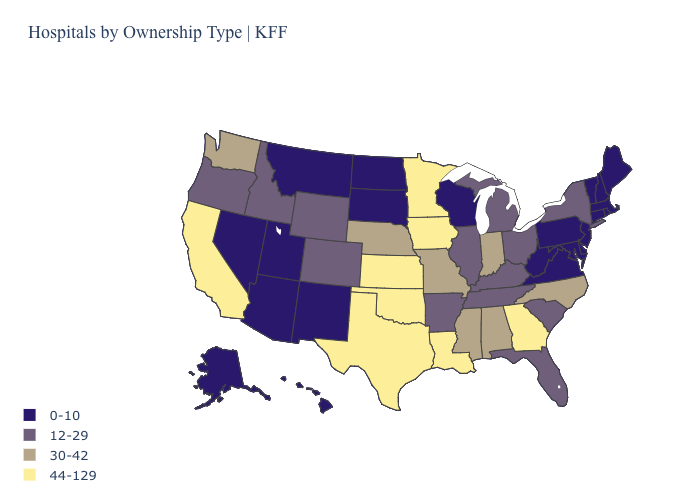What is the value of Wisconsin?
Quick response, please. 0-10. Name the states that have a value in the range 0-10?
Answer briefly. Alaska, Arizona, Connecticut, Delaware, Hawaii, Maine, Maryland, Massachusetts, Montana, Nevada, New Hampshire, New Jersey, New Mexico, North Dakota, Pennsylvania, Rhode Island, South Dakota, Utah, Vermont, Virginia, West Virginia, Wisconsin. Name the states that have a value in the range 44-129?
Concise answer only. California, Georgia, Iowa, Kansas, Louisiana, Minnesota, Oklahoma, Texas. Is the legend a continuous bar?
Keep it brief. No. What is the value of Tennessee?
Be succinct. 12-29. Name the states that have a value in the range 12-29?
Be succinct. Arkansas, Colorado, Florida, Idaho, Illinois, Kentucky, Michigan, New York, Ohio, Oregon, South Carolina, Tennessee, Wyoming. Name the states that have a value in the range 12-29?
Give a very brief answer. Arkansas, Colorado, Florida, Idaho, Illinois, Kentucky, Michigan, New York, Ohio, Oregon, South Carolina, Tennessee, Wyoming. Does Delaware have the highest value in the South?
Short answer required. No. What is the value of Rhode Island?
Write a very short answer. 0-10. What is the highest value in the USA?
Write a very short answer. 44-129. Name the states that have a value in the range 30-42?
Be succinct. Alabama, Indiana, Mississippi, Missouri, Nebraska, North Carolina, Washington. What is the value of New Mexico?
Short answer required. 0-10. Among the states that border Georgia , which have the highest value?
Write a very short answer. Alabama, North Carolina. Does Maine have the same value as Alaska?
Be succinct. Yes. Name the states that have a value in the range 44-129?
Be succinct. California, Georgia, Iowa, Kansas, Louisiana, Minnesota, Oklahoma, Texas. 